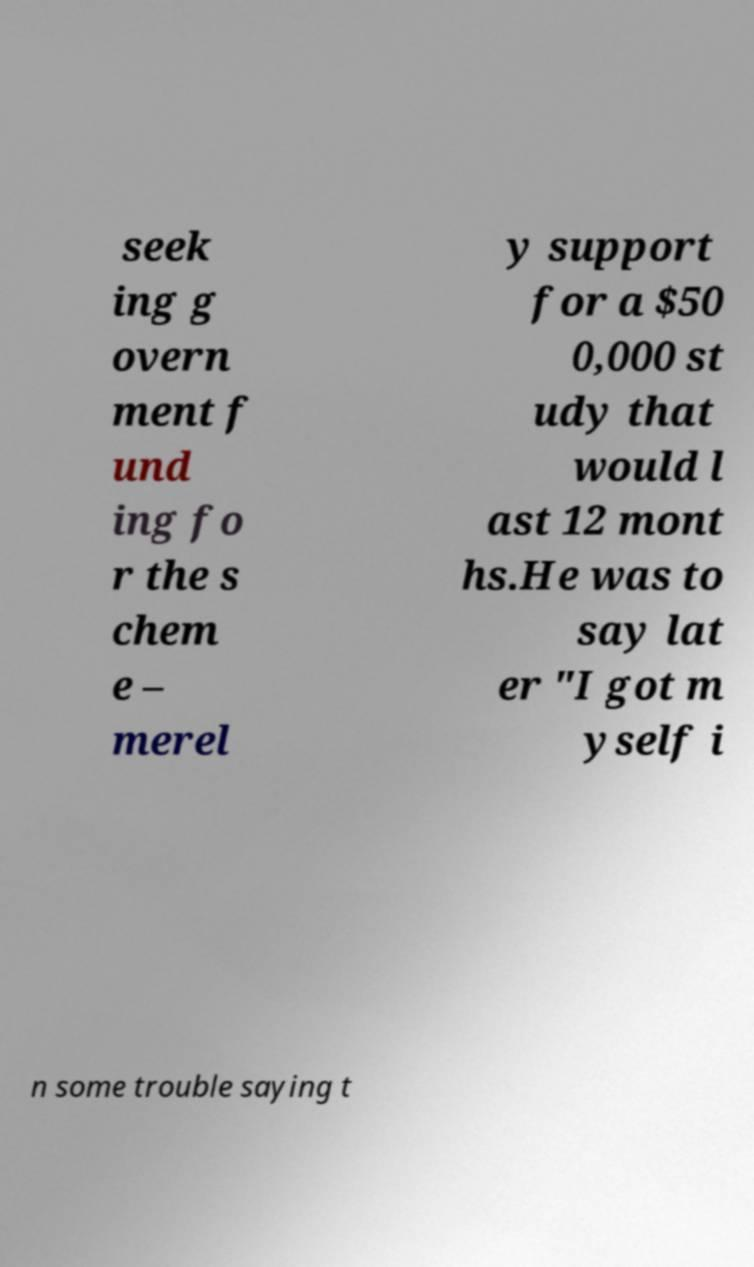What messages or text are displayed in this image? I need them in a readable, typed format. seek ing g overn ment f und ing fo r the s chem e – merel y support for a $50 0,000 st udy that would l ast 12 mont hs.He was to say lat er "I got m yself i n some trouble saying t 